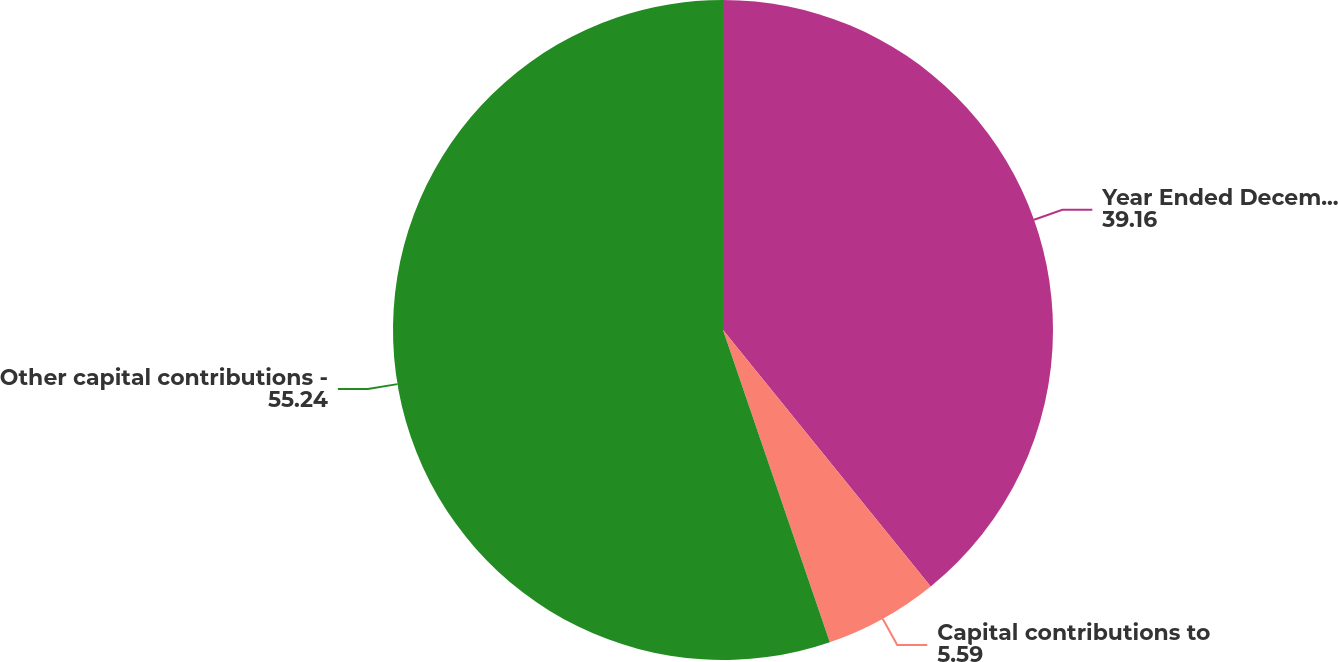<chart> <loc_0><loc_0><loc_500><loc_500><pie_chart><fcel>Year Ended December 31 (in<fcel>Capital contributions to<fcel>Other capital contributions -<nl><fcel>39.16%<fcel>5.59%<fcel>55.24%<nl></chart> 